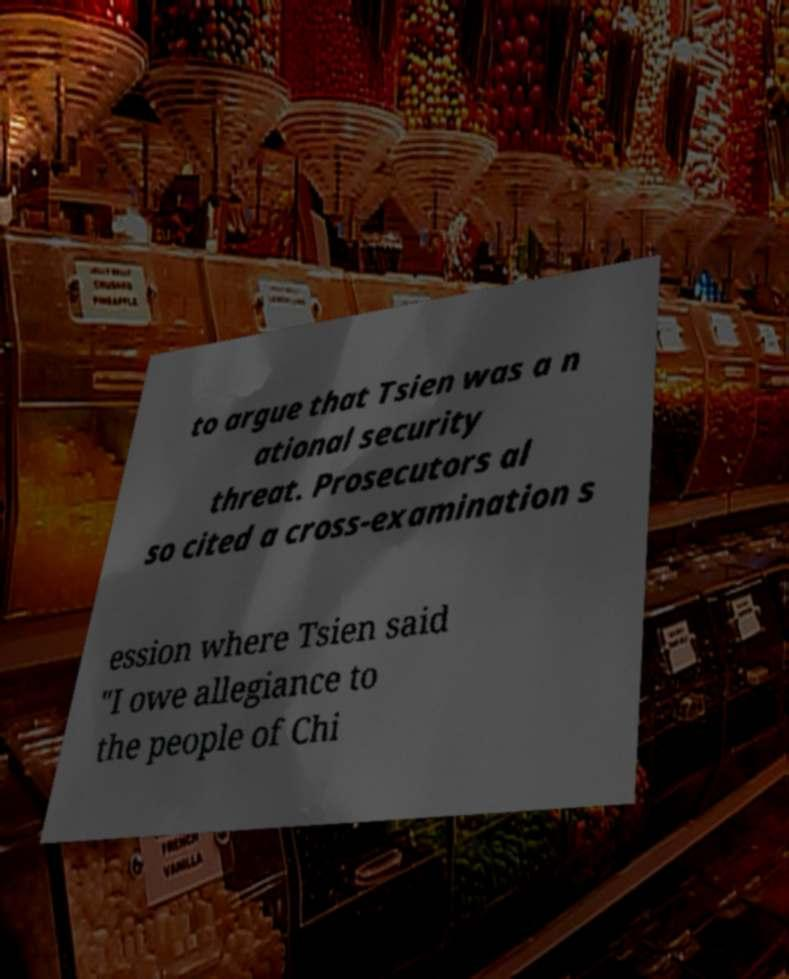Can you accurately transcribe the text from the provided image for me? to argue that Tsien was a n ational security threat. Prosecutors al so cited a cross-examination s ession where Tsien said "I owe allegiance to the people of Chi 